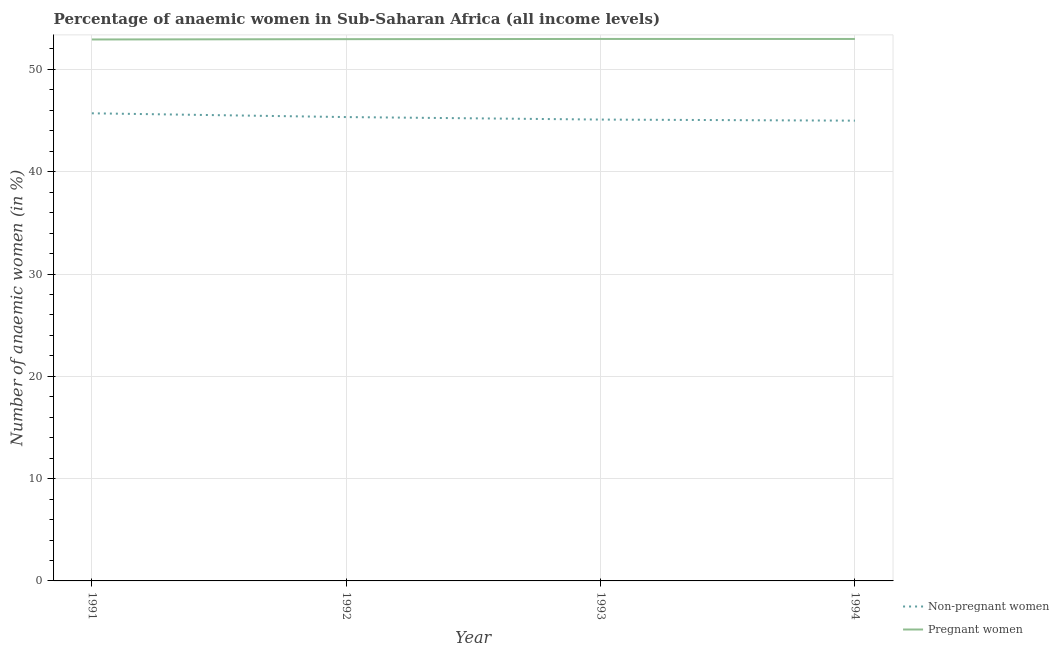How many different coloured lines are there?
Your response must be concise. 2. What is the percentage of non-pregnant anaemic women in 1991?
Provide a succinct answer. 45.71. Across all years, what is the maximum percentage of pregnant anaemic women?
Offer a terse response. 52.98. Across all years, what is the minimum percentage of pregnant anaemic women?
Keep it short and to the point. 52.93. In which year was the percentage of pregnant anaemic women maximum?
Your answer should be very brief. 1993. What is the total percentage of non-pregnant anaemic women in the graph?
Keep it short and to the point. 181.15. What is the difference between the percentage of pregnant anaemic women in 1993 and that in 1994?
Your response must be concise. 0. What is the difference between the percentage of non-pregnant anaemic women in 1994 and the percentage of pregnant anaemic women in 1992?
Offer a terse response. -7.97. What is the average percentage of pregnant anaemic women per year?
Provide a succinct answer. 52.96. In the year 1992, what is the difference between the percentage of non-pregnant anaemic women and percentage of pregnant anaemic women?
Give a very brief answer. -7.62. In how many years, is the percentage of pregnant anaemic women greater than 14 %?
Give a very brief answer. 4. What is the ratio of the percentage of non-pregnant anaemic women in 1991 to that in 1992?
Provide a succinct answer. 1.01. Is the percentage of pregnant anaemic women in 1992 less than that in 1994?
Keep it short and to the point. Yes. Is the difference between the percentage of non-pregnant anaemic women in 1991 and 1992 greater than the difference between the percentage of pregnant anaemic women in 1991 and 1992?
Make the answer very short. Yes. What is the difference between the highest and the second highest percentage of non-pregnant anaemic women?
Provide a short and direct response. 0.37. What is the difference between the highest and the lowest percentage of pregnant anaemic women?
Your answer should be very brief. 0.05. In how many years, is the percentage of non-pregnant anaemic women greater than the average percentage of non-pregnant anaemic women taken over all years?
Your answer should be very brief. 2. Is the sum of the percentage of pregnant anaemic women in 1992 and 1993 greater than the maximum percentage of non-pregnant anaemic women across all years?
Make the answer very short. Yes. Does the percentage of pregnant anaemic women monotonically increase over the years?
Offer a terse response. No. Is the percentage of pregnant anaemic women strictly greater than the percentage of non-pregnant anaemic women over the years?
Offer a very short reply. Yes. How many lines are there?
Make the answer very short. 2. What is the difference between two consecutive major ticks on the Y-axis?
Offer a terse response. 10. Are the values on the major ticks of Y-axis written in scientific E-notation?
Provide a short and direct response. No. What is the title of the graph?
Offer a terse response. Percentage of anaemic women in Sub-Saharan Africa (all income levels). What is the label or title of the Y-axis?
Keep it short and to the point. Number of anaemic women (in %). What is the Number of anaemic women (in %) in Non-pregnant women in 1991?
Provide a succinct answer. 45.71. What is the Number of anaemic women (in %) of Pregnant women in 1991?
Make the answer very short. 52.93. What is the Number of anaemic women (in %) in Non-pregnant women in 1992?
Keep it short and to the point. 45.34. What is the Number of anaemic women (in %) in Pregnant women in 1992?
Your answer should be compact. 52.96. What is the Number of anaemic women (in %) of Non-pregnant women in 1993?
Provide a succinct answer. 45.1. What is the Number of anaemic women (in %) of Pregnant women in 1993?
Offer a very short reply. 52.98. What is the Number of anaemic women (in %) in Non-pregnant women in 1994?
Your answer should be compact. 44.99. What is the Number of anaemic women (in %) of Pregnant women in 1994?
Offer a terse response. 52.98. Across all years, what is the maximum Number of anaemic women (in %) of Non-pregnant women?
Provide a succinct answer. 45.71. Across all years, what is the maximum Number of anaemic women (in %) of Pregnant women?
Make the answer very short. 52.98. Across all years, what is the minimum Number of anaemic women (in %) of Non-pregnant women?
Keep it short and to the point. 44.99. Across all years, what is the minimum Number of anaemic women (in %) in Pregnant women?
Offer a very short reply. 52.93. What is the total Number of anaemic women (in %) of Non-pregnant women in the graph?
Provide a short and direct response. 181.15. What is the total Number of anaemic women (in %) in Pregnant women in the graph?
Make the answer very short. 211.85. What is the difference between the Number of anaemic women (in %) of Non-pregnant women in 1991 and that in 1992?
Your answer should be very brief. 0.37. What is the difference between the Number of anaemic women (in %) of Pregnant women in 1991 and that in 1992?
Your answer should be compact. -0.03. What is the difference between the Number of anaemic women (in %) in Non-pregnant women in 1991 and that in 1993?
Offer a very short reply. 0.61. What is the difference between the Number of anaemic women (in %) of Pregnant women in 1991 and that in 1993?
Offer a terse response. -0.05. What is the difference between the Number of anaemic women (in %) in Non-pregnant women in 1991 and that in 1994?
Make the answer very short. 0.72. What is the difference between the Number of anaemic women (in %) in Pregnant women in 1991 and that in 1994?
Offer a terse response. -0.05. What is the difference between the Number of anaemic women (in %) in Non-pregnant women in 1992 and that in 1993?
Provide a succinct answer. 0.24. What is the difference between the Number of anaemic women (in %) of Pregnant women in 1992 and that in 1993?
Your answer should be compact. -0.02. What is the difference between the Number of anaemic women (in %) in Non-pregnant women in 1992 and that in 1994?
Your answer should be compact. 0.35. What is the difference between the Number of anaemic women (in %) of Pregnant women in 1992 and that in 1994?
Your response must be concise. -0.02. What is the difference between the Number of anaemic women (in %) of Non-pregnant women in 1993 and that in 1994?
Your answer should be compact. 0.11. What is the difference between the Number of anaemic women (in %) of Non-pregnant women in 1991 and the Number of anaemic women (in %) of Pregnant women in 1992?
Your answer should be very brief. -7.25. What is the difference between the Number of anaemic women (in %) in Non-pregnant women in 1991 and the Number of anaemic women (in %) in Pregnant women in 1993?
Keep it short and to the point. -7.27. What is the difference between the Number of anaemic women (in %) of Non-pregnant women in 1991 and the Number of anaemic women (in %) of Pregnant women in 1994?
Ensure brevity in your answer.  -7.27. What is the difference between the Number of anaemic women (in %) in Non-pregnant women in 1992 and the Number of anaemic women (in %) in Pregnant women in 1993?
Your response must be concise. -7.64. What is the difference between the Number of anaemic women (in %) of Non-pregnant women in 1992 and the Number of anaemic women (in %) of Pregnant women in 1994?
Give a very brief answer. -7.63. What is the difference between the Number of anaemic women (in %) in Non-pregnant women in 1993 and the Number of anaemic women (in %) in Pregnant women in 1994?
Offer a very short reply. -7.88. What is the average Number of anaemic women (in %) of Non-pregnant women per year?
Your response must be concise. 45.29. What is the average Number of anaemic women (in %) of Pregnant women per year?
Give a very brief answer. 52.96. In the year 1991, what is the difference between the Number of anaemic women (in %) of Non-pregnant women and Number of anaemic women (in %) of Pregnant women?
Give a very brief answer. -7.22. In the year 1992, what is the difference between the Number of anaemic women (in %) of Non-pregnant women and Number of anaemic women (in %) of Pregnant women?
Offer a very short reply. -7.62. In the year 1993, what is the difference between the Number of anaemic women (in %) of Non-pregnant women and Number of anaemic women (in %) of Pregnant women?
Offer a terse response. -7.88. In the year 1994, what is the difference between the Number of anaemic women (in %) in Non-pregnant women and Number of anaemic women (in %) in Pregnant women?
Your answer should be compact. -7.99. What is the ratio of the Number of anaemic women (in %) of Non-pregnant women in 1991 to that in 1992?
Provide a succinct answer. 1.01. What is the ratio of the Number of anaemic women (in %) in Non-pregnant women in 1991 to that in 1993?
Give a very brief answer. 1.01. What is the ratio of the Number of anaemic women (in %) in Pregnant women in 1991 to that in 1994?
Give a very brief answer. 1. What is the ratio of the Number of anaemic women (in %) of Non-pregnant women in 1992 to that in 1993?
Offer a very short reply. 1.01. What is the ratio of the Number of anaemic women (in %) in Non-pregnant women in 1993 to that in 1994?
Give a very brief answer. 1. What is the ratio of the Number of anaemic women (in %) in Pregnant women in 1993 to that in 1994?
Give a very brief answer. 1. What is the difference between the highest and the second highest Number of anaemic women (in %) in Non-pregnant women?
Ensure brevity in your answer.  0.37. What is the difference between the highest and the lowest Number of anaemic women (in %) of Non-pregnant women?
Provide a short and direct response. 0.72. What is the difference between the highest and the lowest Number of anaemic women (in %) in Pregnant women?
Offer a very short reply. 0.05. 